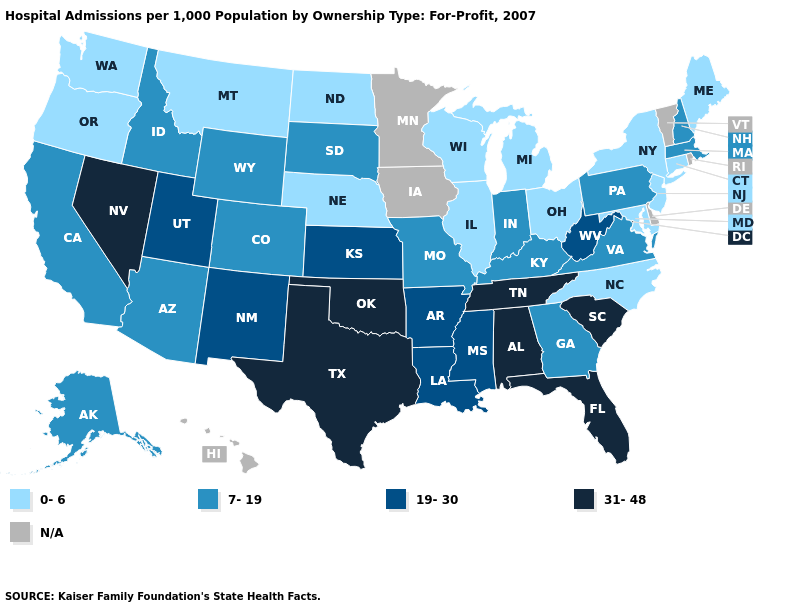Does Louisiana have the highest value in the South?
Keep it brief. No. Does the map have missing data?
Short answer required. Yes. What is the value of Oklahoma?
Give a very brief answer. 31-48. Which states have the highest value in the USA?
Keep it brief. Alabama, Florida, Nevada, Oklahoma, South Carolina, Tennessee, Texas. Name the states that have a value in the range N/A?
Concise answer only. Delaware, Hawaii, Iowa, Minnesota, Rhode Island, Vermont. Which states have the highest value in the USA?
Write a very short answer. Alabama, Florida, Nevada, Oklahoma, South Carolina, Tennessee, Texas. Among the states that border Louisiana , which have the highest value?
Short answer required. Texas. Among the states that border Michigan , which have the highest value?
Short answer required. Indiana. What is the highest value in states that border Illinois?
Write a very short answer. 7-19. Name the states that have a value in the range 7-19?
Write a very short answer. Alaska, Arizona, California, Colorado, Georgia, Idaho, Indiana, Kentucky, Massachusetts, Missouri, New Hampshire, Pennsylvania, South Dakota, Virginia, Wyoming. What is the value of Missouri?
Concise answer only. 7-19. Name the states that have a value in the range 0-6?
Answer briefly. Connecticut, Illinois, Maine, Maryland, Michigan, Montana, Nebraska, New Jersey, New York, North Carolina, North Dakota, Ohio, Oregon, Washington, Wisconsin. Does the map have missing data?
Concise answer only. Yes. 